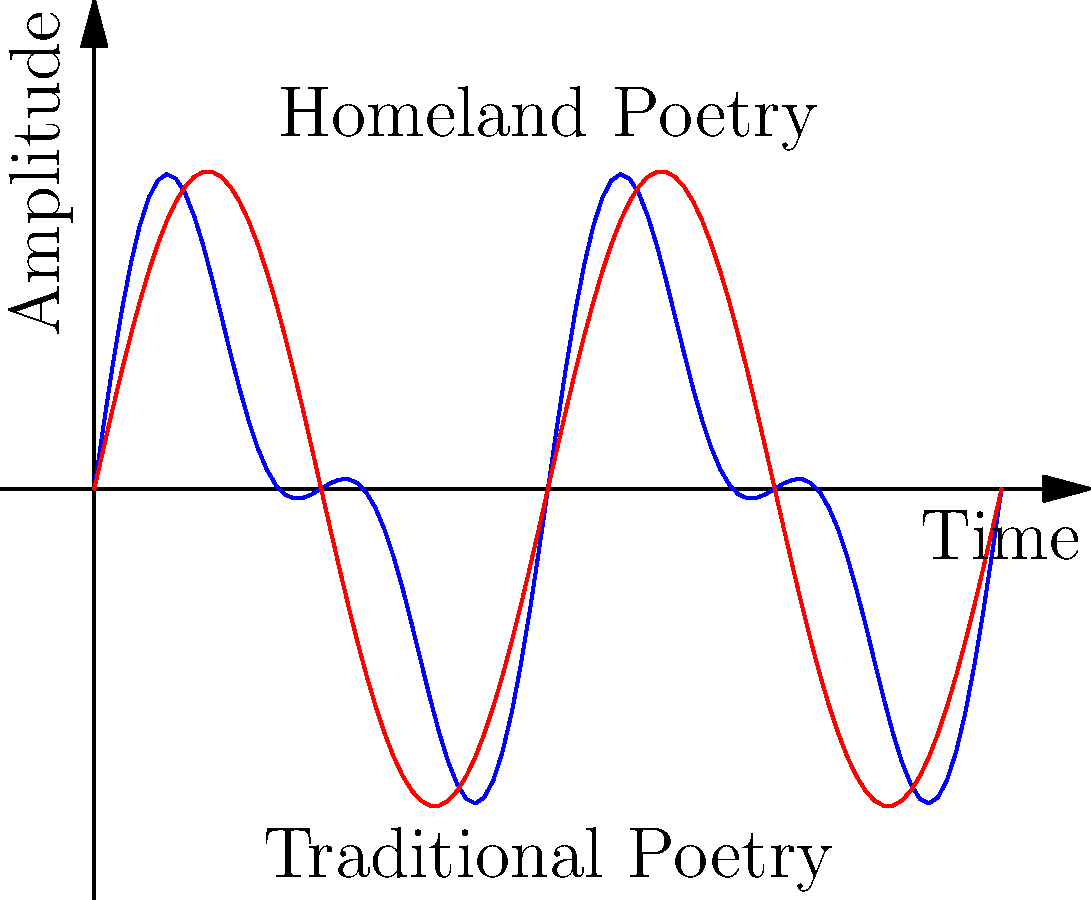In the graph above, the blue curve represents the rhythm of a poem inspired by your parent's homeland, while the red curve represents a traditional poem. Both curves can be described by wave functions. If the blue curve is represented by the function $f(x) = 0.5\sin(2\pi x) + 0.3\sin(4\pi x)$ and the red curve by $g(x) = 0.7\sin(2\pi x)$, what is the ratio of the frequency of the highest frequency component in the homeland poem to that of the traditional poem? To solve this problem, we need to follow these steps:

1) First, let's identify the frequency components in each function:

   For $f(x) = 0.5\sin(2\pi x) + 0.3\sin(4\pi x)$:
   - First component: $2\pi x$
   - Second component: $4\pi x$

   For $g(x) = 0.7\sin(2\pi x)$:
   - Only component: $2\pi x$

2) The frequency of a sine wave is determined by the coefficient of $x$ inside the sine function.

3) For $f(x)$, the highest frequency component is $4\pi x$.
   For $g(x)$, the only frequency component is $2\pi x$.

4) To find the ratio, we divide the higher frequency by the lower:

   $\frac{4\pi}{2\pi} = 2$

Therefore, the highest frequency component in the homeland poem is twice that of the traditional poem.
Answer: 2 